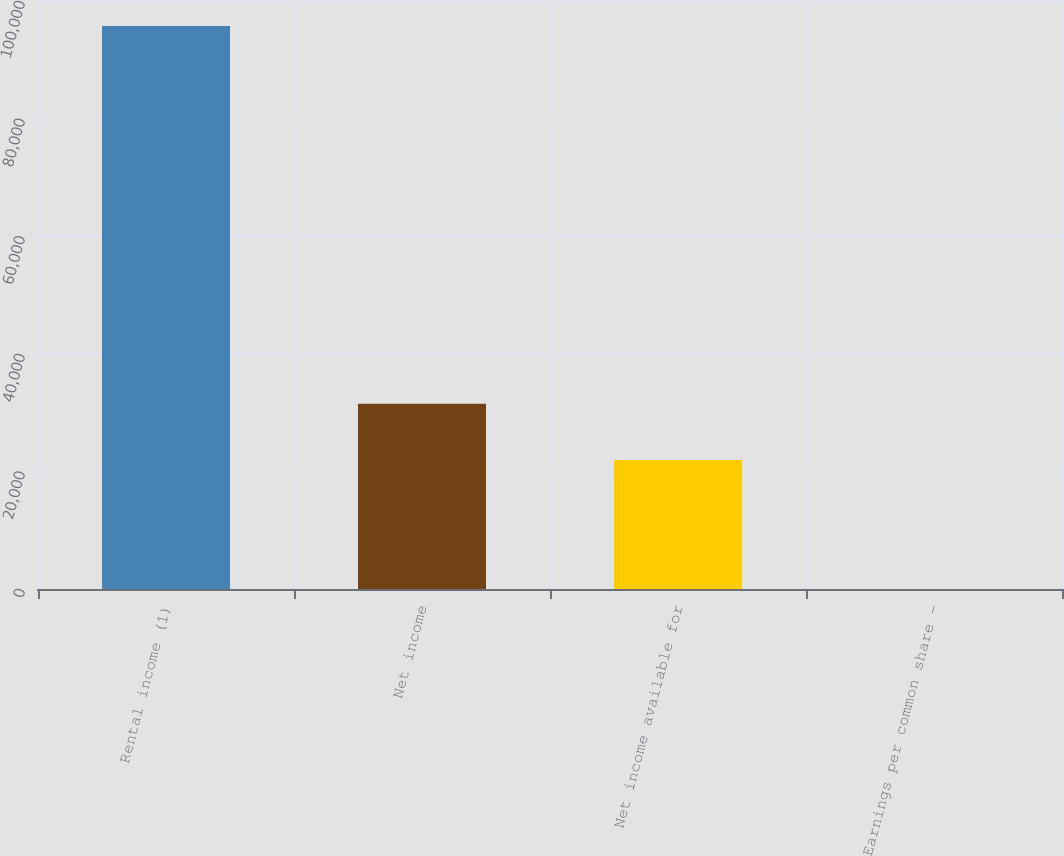Convert chart. <chart><loc_0><loc_0><loc_500><loc_500><bar_chart><fcel>Rental income (1)<fcel>Net income<fcel>Net income available for<fcel>Earnings per common share -<nl><fcel>95762<fcel>31514.2<fcel>21938<fcel>0.41<nl></chart> 